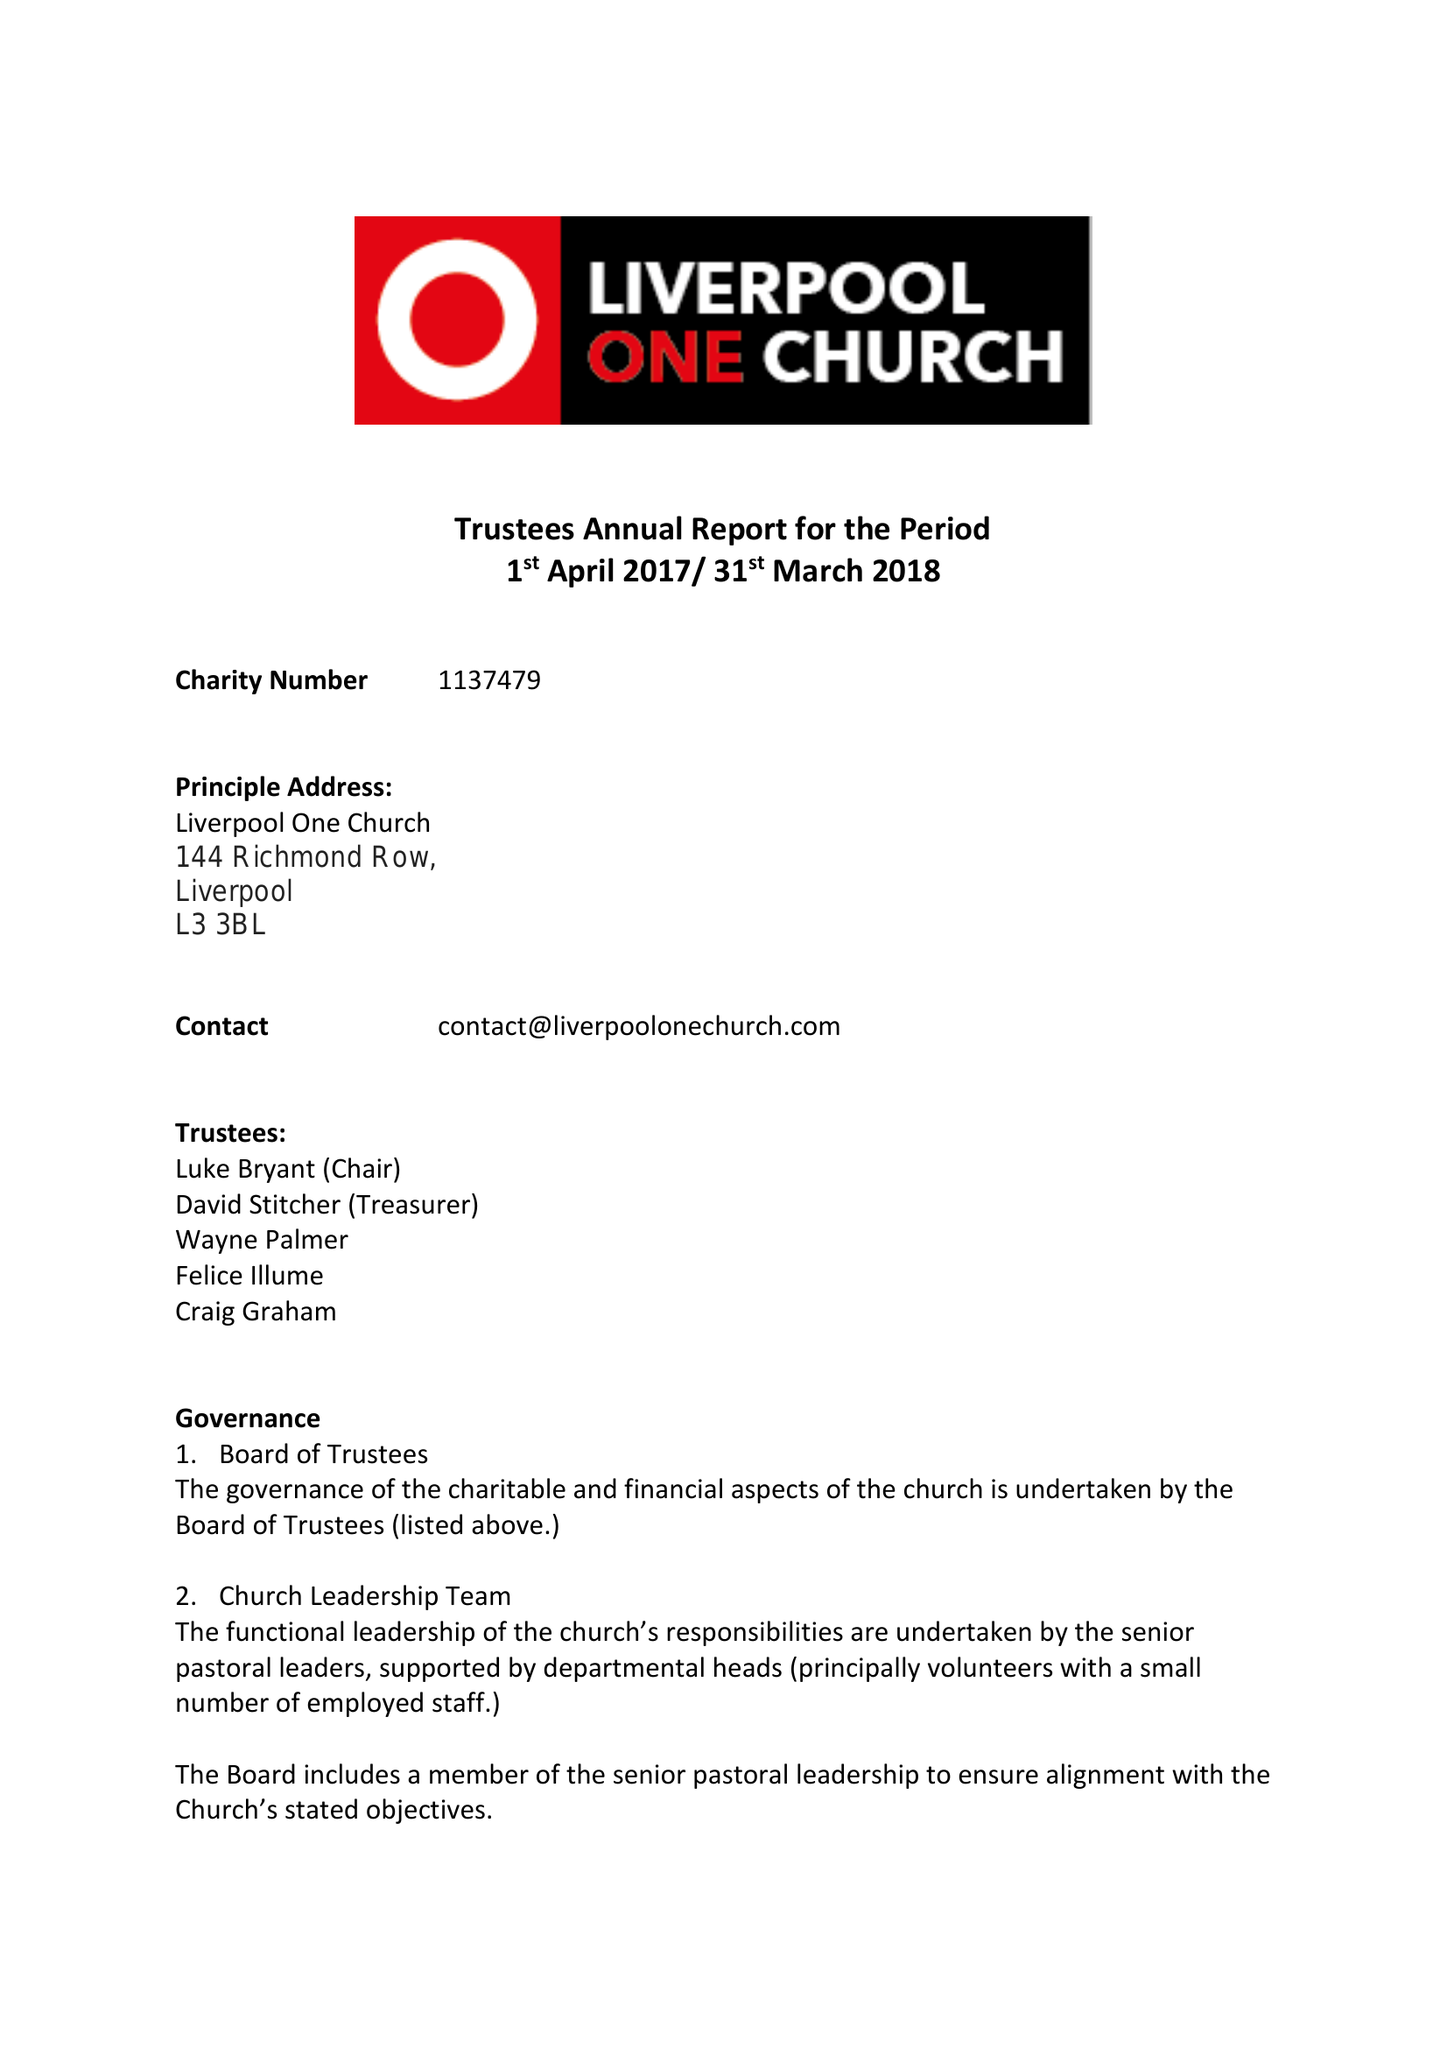What is the value for the income_annually_in_british_pounds?
Answer the question using a single word or phrase. 243574.00 